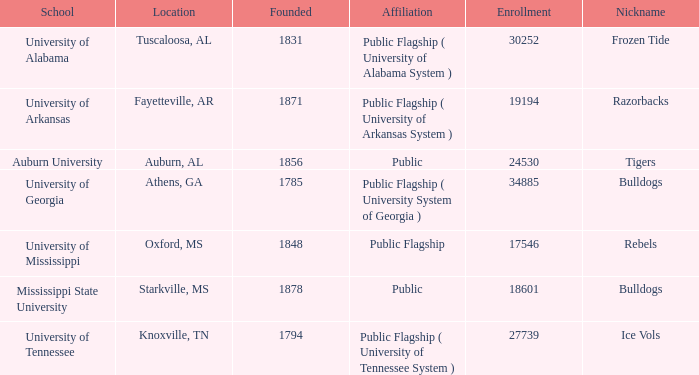What is the popular moniker for the university of alabama? Frozen Tide. 